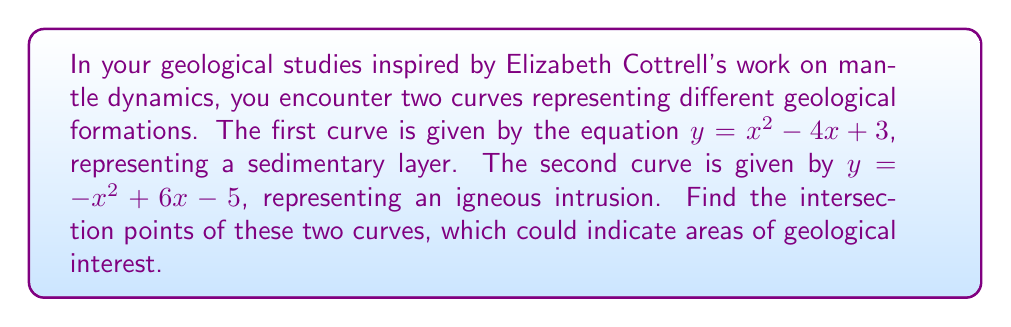What is the answer to this math problem? To find the intersection points, we need to solve the system of equations:

$$\begin{cases}
y = x^2 - 4x + 3 \\
y = -x^2 + 6x - 5
\end{cases}$$

Step 1: Set the equations equal to each other since they represent the same y-value at the intersection points.
$x^2 - 4x + 3 = -x^2 + 6x - 5$

Step 2: Rearrange the equation to standard form.
$2x^2 - 10x + 8 = 0$

Step 3: Divide all terms by 2 to simplify.
$x^2 - 5x + 4 = 0$

Step 4: Use the quadratic formula to solve for x. The quadratic formula is $x = \frac{-b \pm \sqrt{b^2 - 4ac}}{2a}$, where $a=1$, $b=-5$, and $c=4$.

$x = \frac{5 \pm \sqrt{25 - 16}}{2} = \frac{5 \pm 3}{2}$

Step 5: Solve for the two x-values.
$x_1 = \frac{5 + 3}{2} = 4$ and $x_2 = \frac{5 - 3}{2} = 1$

Step 6: Find the corresponding y-values by substituting these x-values into either of the original equations. Let's use $y = x^2 - 4x + 3$.

For $x_1 = 4$: $y = 4^2 - 4(4) + 3 = 16 - 16 + 3 = 3$
For $x_2 = 1$: $y = 1^2 - 4(1) + 3 = 1 - 4 + 3 = 0$

Therefore, the intersection points are (4, 3) and (1, 0).
Answer: (4, 3) and (1, 0) 